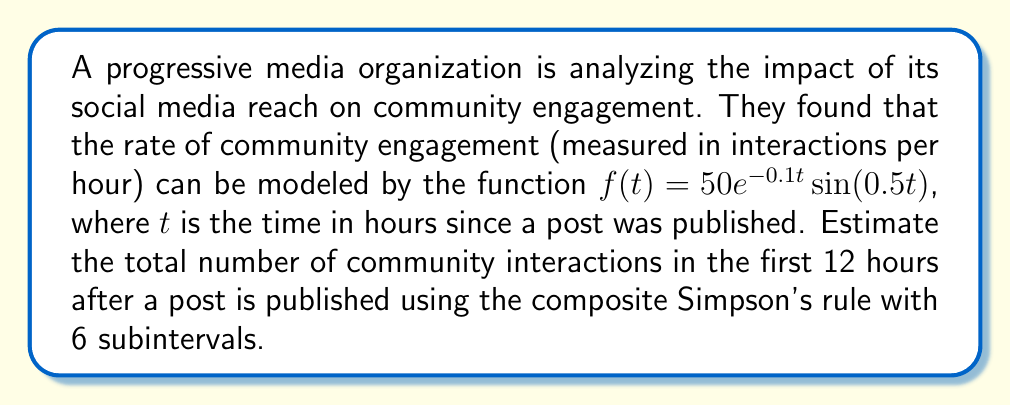Give your solution to this math problem. To estimate the total number of community interactions, we need to integrate the rate function $f(t)$ over the interval $[0, 12]$. We'll use the composite Simpson's rule with 6 subintervals.

The composite Simpson's rule is given by:

$$\int_{a}^{b} f(x) dx \approx \frac{h}{3}\left[f(x_0) + 4f(x_1) + 2f(x_2) + 4f(x_3) + 2f(x_4) + 4f(x_5) + f(x_6)\right]$$

where $h = \frac{b-a}{n}$, $n$ is the number of subintervals (6 in this case), and $x_i = a + ih$ for $i = 0, 1, ..., n$.

Step 1: Calculate $h$
$h = \frac{12 - 0}{6} = 2$

Step 2: Calculate the $x_i$ values
$x_0 = 0$, $x_1 = 2$, $x_2 = 4$, $x_3 = 6$, $x_4 = 8$, $x_5 = 10$, $x_6 = 12$

Step 3: Evaluate $f(x_i)$ for each $x_i$
$f(0) = 50e^{-0.1 \cdot 0}\sin(0.5 \cdot 0) = 0$
$f(2) = 50e^{-0.1 \cdot 2}\sin(0.5 \cdot 2) \approx 40.6511$
$f(4) = 50e^{-0.1 \cdot 4}\sin(0.5 \cdot 4) \approx 33.0272$
$f(6) = 50e^{-0.1 \cdot 6}\sin(0.5 \cdot 6) \approx 0.8103$
$f(8) = 50e^{-0.1 \cdot 8}\sin(0.5 \cdot 8) \approx -21.7798$
$f(10) = 50e^{-0.1 \cdot 10}\sin(0.5 \cdot 10) \approx -17.6751$
$f(12) = 50e^{-0.1 \cdot 12}\sin(0.5 \cdot 12) \approx -0.4335$

Step 4: Apply the composite Simpson's rule
$$\begin{align*}
\int_{0}^{12} f(t) dt &\approx \frac{2}{3}[0 + 4(40.6511) + 2(33.0272) + 4(0.8103) \\
&\quad + 2(-21.7798) + 4(-17.6751) + (-0.4335)] \\
&\approx \frac{2}{3}[0 + 162.6044 + 66.0544 + 3.2412 - 43.5596 - 70.7004 - 0.4335] \\
&\approx \frac{2}{3}[117.2065] \\
&\approx 78.1377
\end{align*}$$

Therefore, the estimated total number of community interactions in the first 12 hours after a post is published is approximately 78.1377.
Answer: 78.1377 interactions 